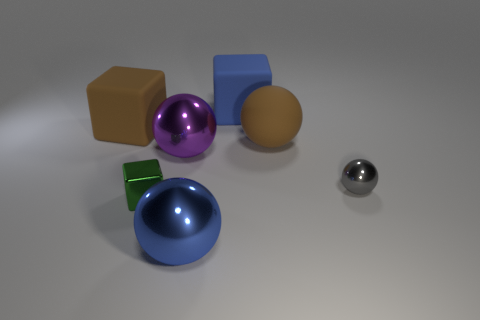The sphere that is to the left of the big blue matte block and behind the gray shiny ball is made of what material?
Give a very brief answer. Metal. There is a ball to the right of the large brown ball; are there any big rubber spheres right of it?
Keep it short and to the point. No. How many large rubber blocks have the same color as the tiny metal block?
Your answer should be very brief. 0. Do the green thing and the big brown sphere have the same material?
Keep it short and to the point. No. Are there any blocks right of the big purple ball?
Offer a very short reply. Yes. What is the material of the big brown thing on the left side of the rubber cube right of the large brown matte block?
Provide a succinct answer. Rubber. The brown thing that is the same shape as the blue metallic object is what size?
Make the answer very short. Large. Is the color of the tiny metal sphere the same as the large matte sphere?
Ensure brevity in your answer.  No. The cube that is right of the brown cube and behind the gray object is what color?
Offer a very short reply. Blue. There is a blue thing that is in front of the blue cube; does it have the same size as the tiny sphere?
Offer a terse response. No. 